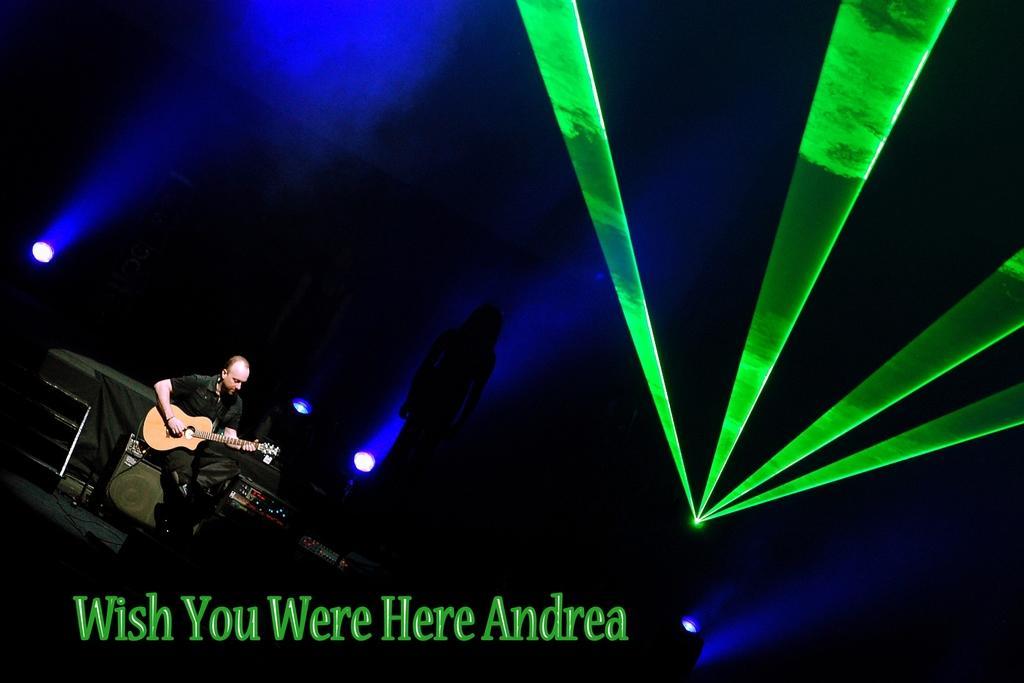Can you describe this image briefly? In this image I can see a person sitting and playing guitar and there are also some lights in the image. 